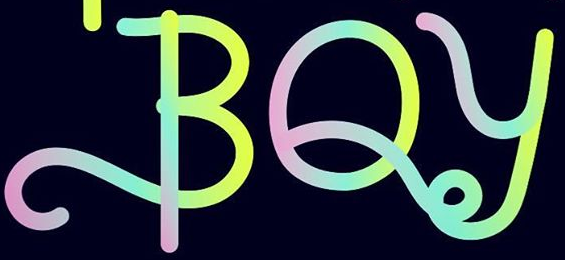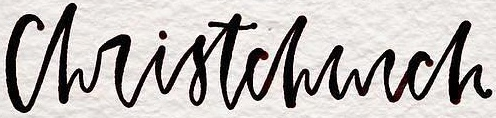Transcribe the words shown in these images in order, separated by a semicolon. BOy; christchurch 